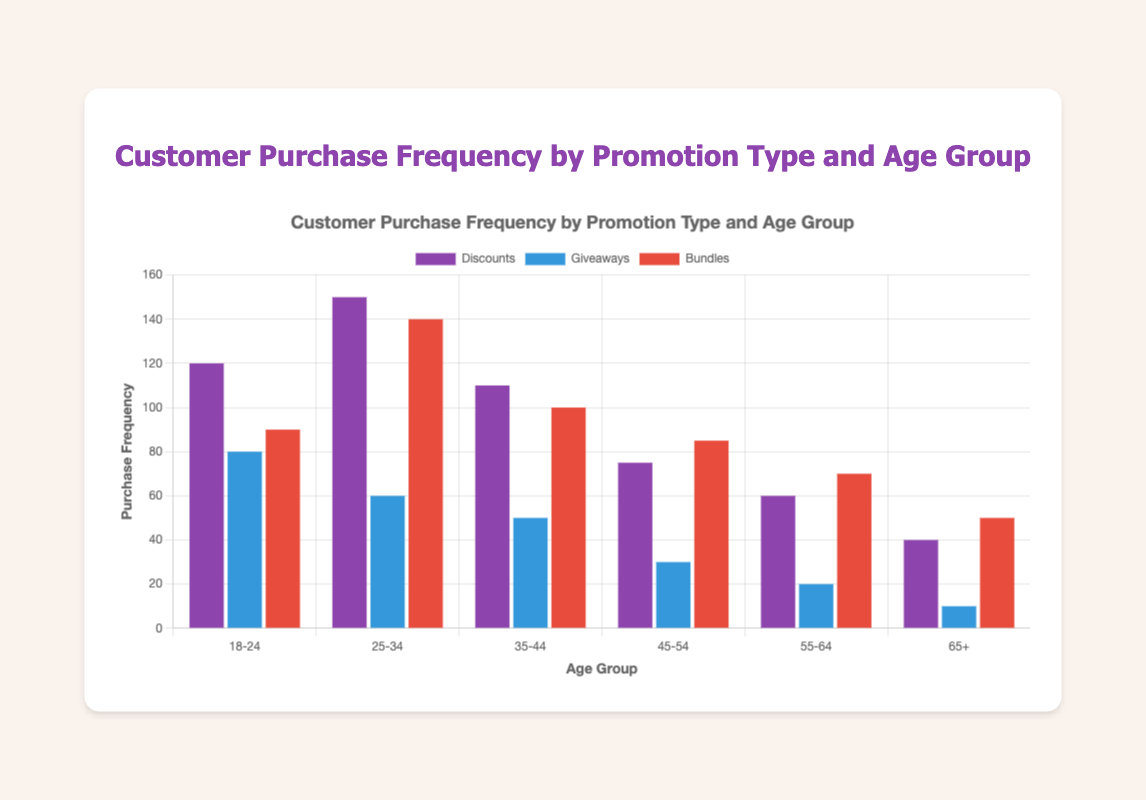Which age group has the highest purchase frequency for Discounts? The age group with the highest purchase frequency for Discounts can be identified by comparing the heights of the bars labeled "Discounts." The highest bar corresponds to the 25-34 age group with 150 purchases.
Answer: 25-34 How does the purchase frequency for Giveaways in the 18-24 age group compare to the 35-44 age group? Compare the heights of the bars labeled "Giveaways" for both age groups. The 18-24 age group has an 80 purchase frequency, while the 35-44 age group has a 50 purchase frequency.
Answer: Higher What is the sum of purchase frequencies for the 45-54 age group across all promotion types? To find the sum, add the purchase frequencies for Discounts, Giveaways, and Bundles in the 45-54 age group: 75 (Discounts) + 30 (Giveaways) + 85 (Bundles) = 190.
Answer: 190 Which promotion type has the lowest purchase frequency in the 55-64 age group? Compare the heights of bars for Discounts, Giveaways, and Bundles in the 55-64 age group. Giveaways have the lowest purchase frequency at 20.
Answer: Giveaways What is the average purchase frequency for Bundles across all age groups? Sum the purchase frequencies for Bundles across all age groups and divide by the number of age groups: (90 + 140 + 100 + 85 + 70 + 50) / 6 = 88.33.
Answer: 88.33 Which two age groups have the same purchase frequency for Giveaways, and what is that frequency? The bar heights for Giveaways are compared across all age groups. The 25-34 and 35-44 age groups both have a purchase frequency of 50.
Answer: 25-34 and 35-44, 50 What is the difference in purchase frequency between Discounts and Bundles for the 18-24 age group? Subtract the purchase frequency of Bundles from Discounts for the 18-24 age group: 120 (Discounts) - 90 (Bundles) = 30.
Answer: 30 For which promotion type does the 65+ age group have the highest purchase frequency, and what is the value? Compare the heights of the bars for Discounts, Giveaways, and Bundles in the 65+ age group. The highest purchase frequency is for Bundles, with a value of 50.
Answer: Bundles, 50 